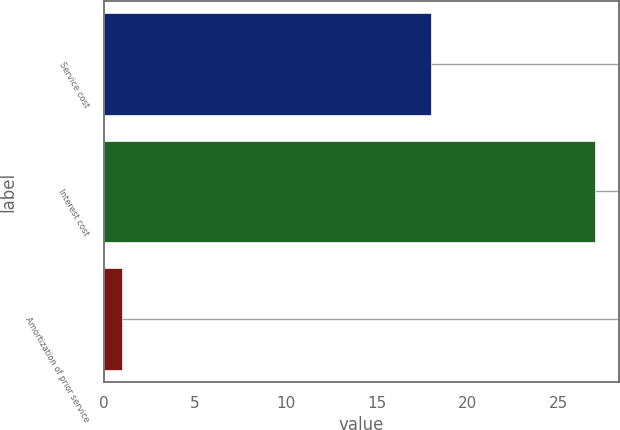Convert chart to OTSL. <chart><loc_0><loc_0><loc_500><loc_500><bar_chart><fcel>Service cost<fcel>Interest cost<fcel>Amortization of prior service<nl><fcel>18<fcel>27<fcel>1<nl></chart> 